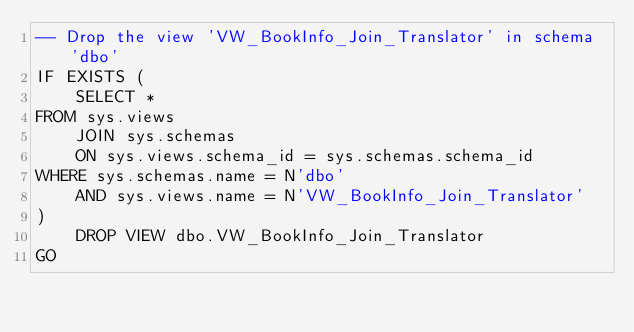<code> <loc_0><loc_0><loc_500><loc_500><_SQL_>-- Drop the view 'VW_BookInfo_Join_Translator' in schema 'dbo'
IF EXISTS (
    SELECT *
FROM sys.views
    JOIN sys.schemas
    ON sys.views.schema_id = sys.schemas.schema_id
WHERE sys.schemas.name = N'dbo'
    AND sys.views.name = N'VW_BookInfo_Join_Translator'
)
    DROP VIEW dbo.VW_BookInfo_Join_Translator
GO</code> 